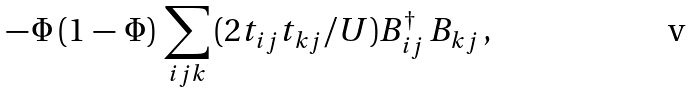<formula> <loc_0><loc_0><loc_500><loc_500>- \, \Phi \, ( 1 \, - \, \Phi ) \, \sum _ { i j k } \, ( 2 t _ { i j } t _ { k j } / U ) B _ { i j } ^ { \dagger } \, B _ { k j } \, ,</formula> 